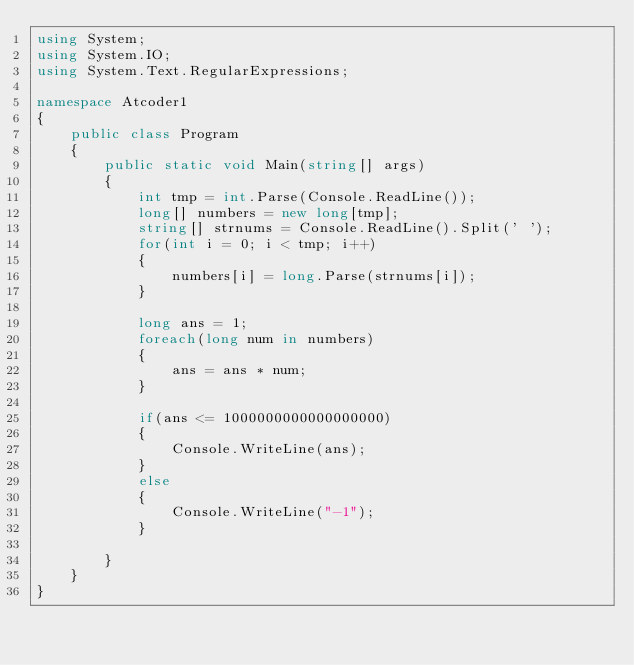<code> <loc_0><loc_0><loc_500><loc_500><_C#_>using System;
using System.IO;
using System.Text.RegularExpressions;

namespace Atcoder1
{
    public class Program
    {
        public static void Main(string[] args)
        {
            int tmp = int.Parse(Console.ReadLine());
            long[] numbers = new long[tmp];
            string[] strnums = Console.ReadLine().Split(' ');
            for(int i = 0; i < tmp; i++)
            {
                numbers[i] = long.Parse(strnums[i]);
            }

            long ans = 1;
            foreach(long num in numbers)
            {
                ans = ans * num;
            }

            if(ans <= 1000000000000000000)
            {
                Console.WriteLine(ans);
            }
            else
            {
                Console.WriteLine("-1");
            }

        }
    }
}</code> 